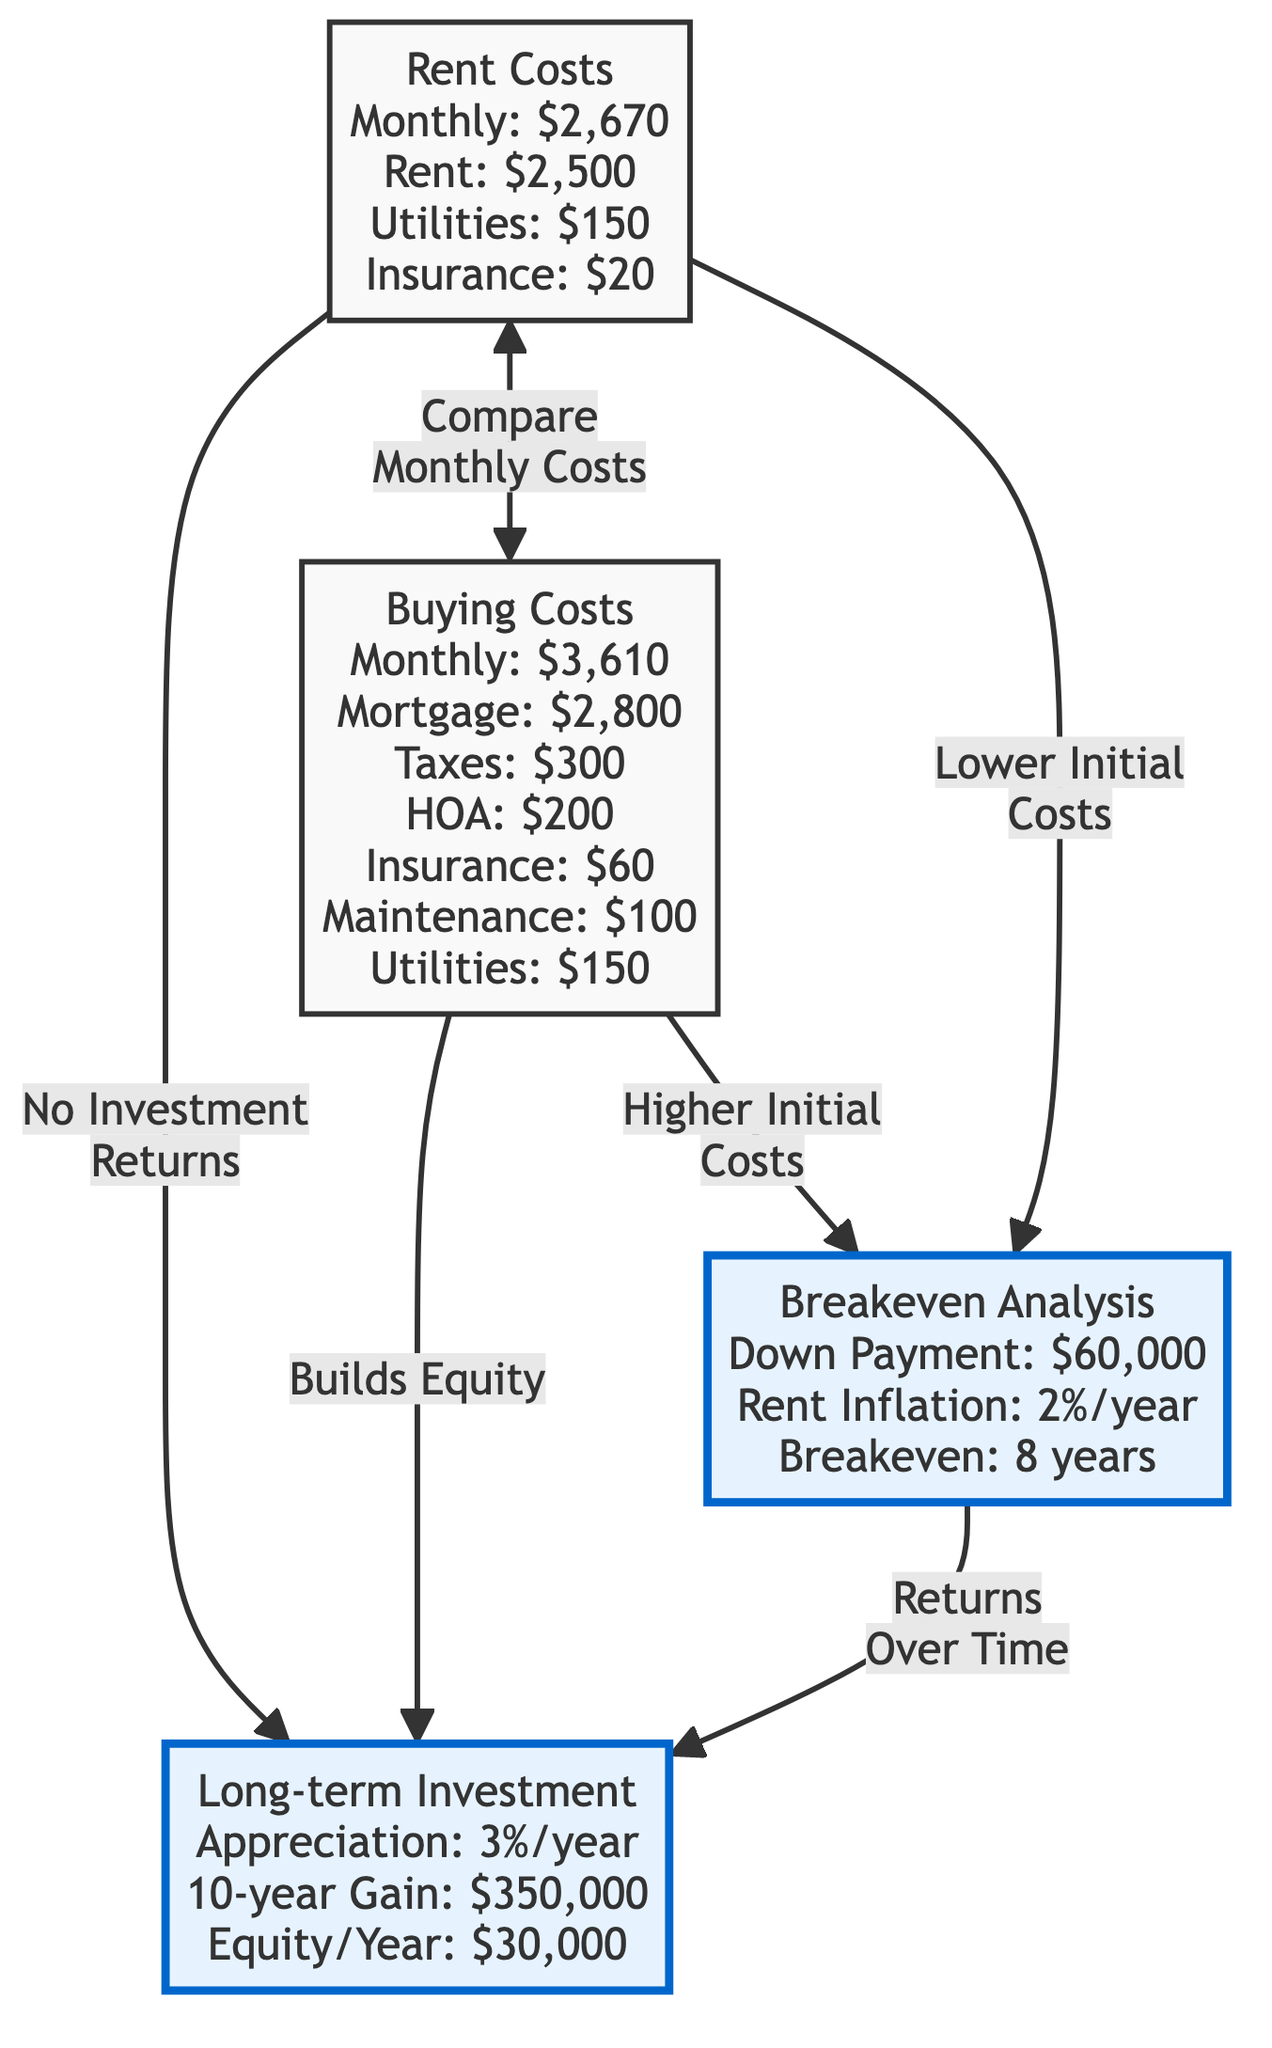What is the monthly rent cost? The diagram lists the monthly rent cost as $2,500. By checking the node labeled "Rent Costs," we find that the rent is specified directly.
Answer: $2,500 What is the monthly mortgage payment when buying? The diagram indicates that the monthly mortgage payment when buying a property is $2,800. This information is found in the node labeled "Buying Costs."
Answer: $2,800 What is the total monthly cost of renting? The total monthly cost of renting is found by adding utilities and insurance to the base rent. The rent is $2,500, utilities are $150, and insurance is $20. Therefore, the total monthly cost is $2,500 + $150 + $20 = $2,670.
Answer: $2,670 How much will appreciation yield in 10 years? According to the diagram, the 10-year gain from appreciation is stated as $350,000. This information is found in the "Long-term Investment" node, which outlines the expected returns from property appreciation over a decade.
Answer: $350,000 What is the breakeven point in years? The diagram indicates that the breakeven point is 8 years. This is detailed in the "Breakeven Analysis" node, which concludes how long it takes for the costs of buying to equal the costs of renting.
Answer: 8 years What is the down payment needed to buy? The down payment needed for purchasing is specified as $60,000 in the "Breakeven Analysis" section of the diagram.
Answer: $60,000 What is the yearly equity built by owning? The yearly equity built by owning a property is given as $30,000, which can be found in the "Long-term Investment" node. This represents the difference in value gained by owning compared to renting.
Answer: $30,000 Which costs are associated with renting? The diagram outlines that renting incurs costs of $2,500 for rent, $150 for utilities, and $20 for insurance. These details are in the "Rent Costs" node.
Answer: Rent, Utilities, Insurance What does renting not provide in comparison to buying? Renting does not build equity, as indicated in the diagram with the phrase "No Investment Returns" connected to the renting costs node. This establishes a significant difference from the buying option, which allows for equity building.
Answer: Equity 